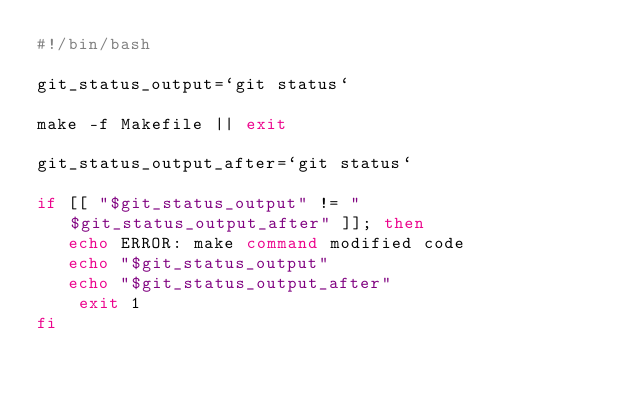Convert code to text. <code><loc_0><loc_0><loc_500><loc_500><_Bash_>#!/bin/bash

git_status_output=`git status`

make -f Makefile || exit

git_status_output_after=`git status`

if [[ "$git_status_output" != "$git_status_output_after" ]]; then
   echo ERROR: make command modified code
   echo "$git_status_output"
   echo "$git_status_output_after"
    exit 1
fi

</code> 